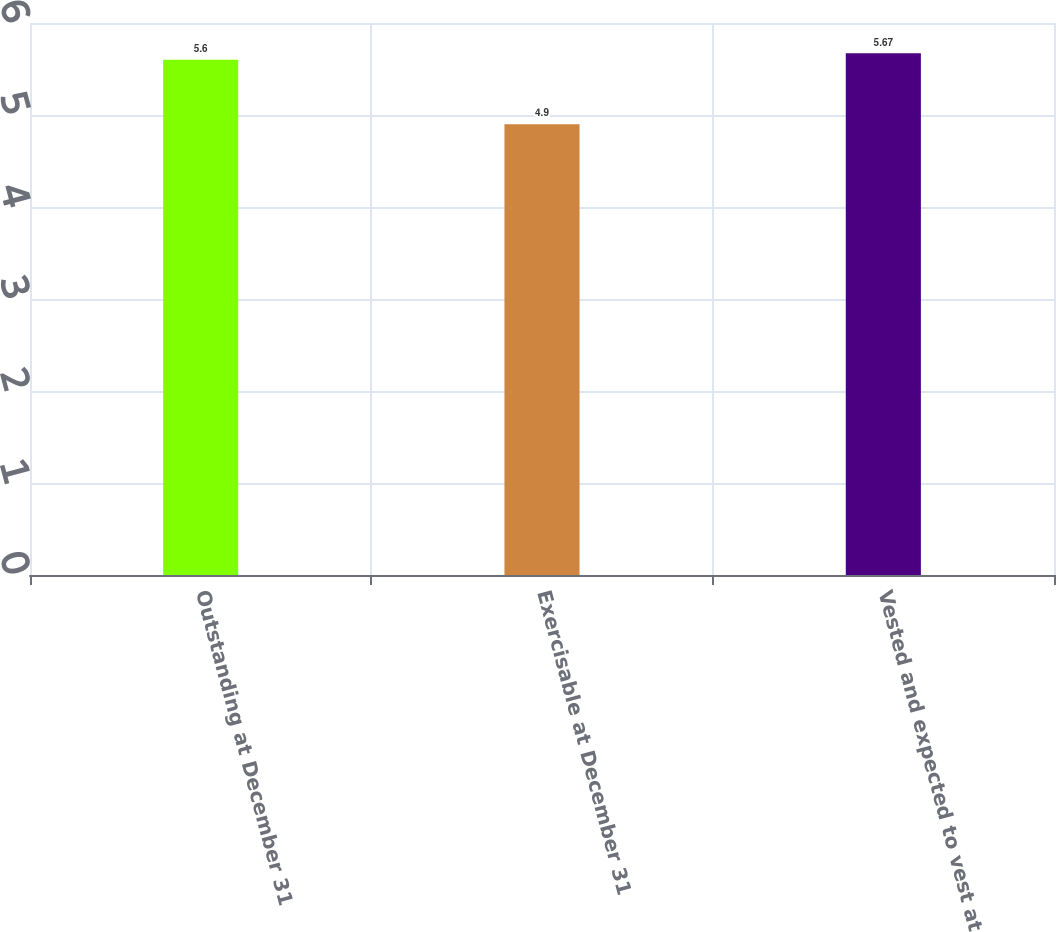Convert chart to OTSL. <chart><loc_0><loc_0><loc_500><loc_500><bar_chart><fcel>Outstanding at December 31<fcel>Exercisable at December 31<fcel>Vested and expected to vest at<nl><fcel>5.6<fcel>4.9<fcel>5.67<nl></chart> 